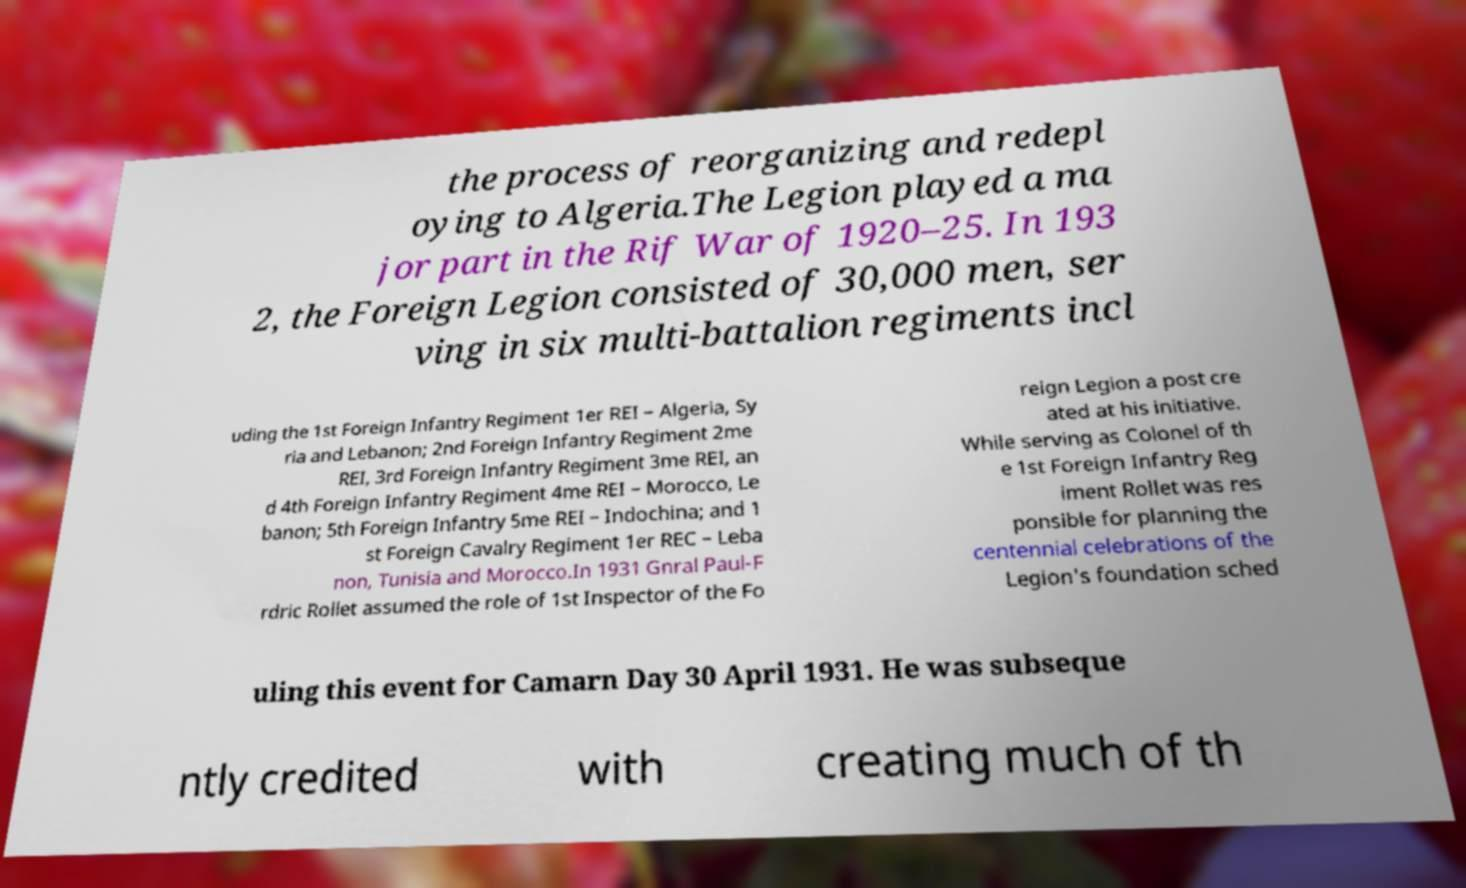What messages or text are displayed in this image? I need them in a readable, typed format. the process of reorganizing and redepl oying to Algeria.The Legion played a ma jor part in the Rif War of 1920–25. In 193 2, the Foreign Legion consisted of 30,000 men, ser ving in six multi-battalion regiments incl uding the 1st Foreign Infantry Regiment 1er REI – Algeria, Sy ria and Lebanon; 2nd Foreign Infantry Regiment 2me REI, 3rd Foreign Infantry Regiment 3me REI, an d 4th Foreign Infantry Regiment 4me REI – Morocco, Le banon; 5th Foreign Infantry 5me REI – Indochina; and 1 st Foreign Cavalry Regiment 1er REC – Leba non, Tunisia and Morocco.In 1931 Gnral Paul-F rdric Rollet assumed the role of 1st Inspector of the Fo reign Legion a post cre ated at his initiative. While serving as Colonel of th e 1st Foreign Infantry Reg iment Rollet was res ponsible for planning the centennial celebrations of the Legion's foundation sched uling this event for Camarn Day 30 April 1931. He was subseque ntly credited with creating much of th 